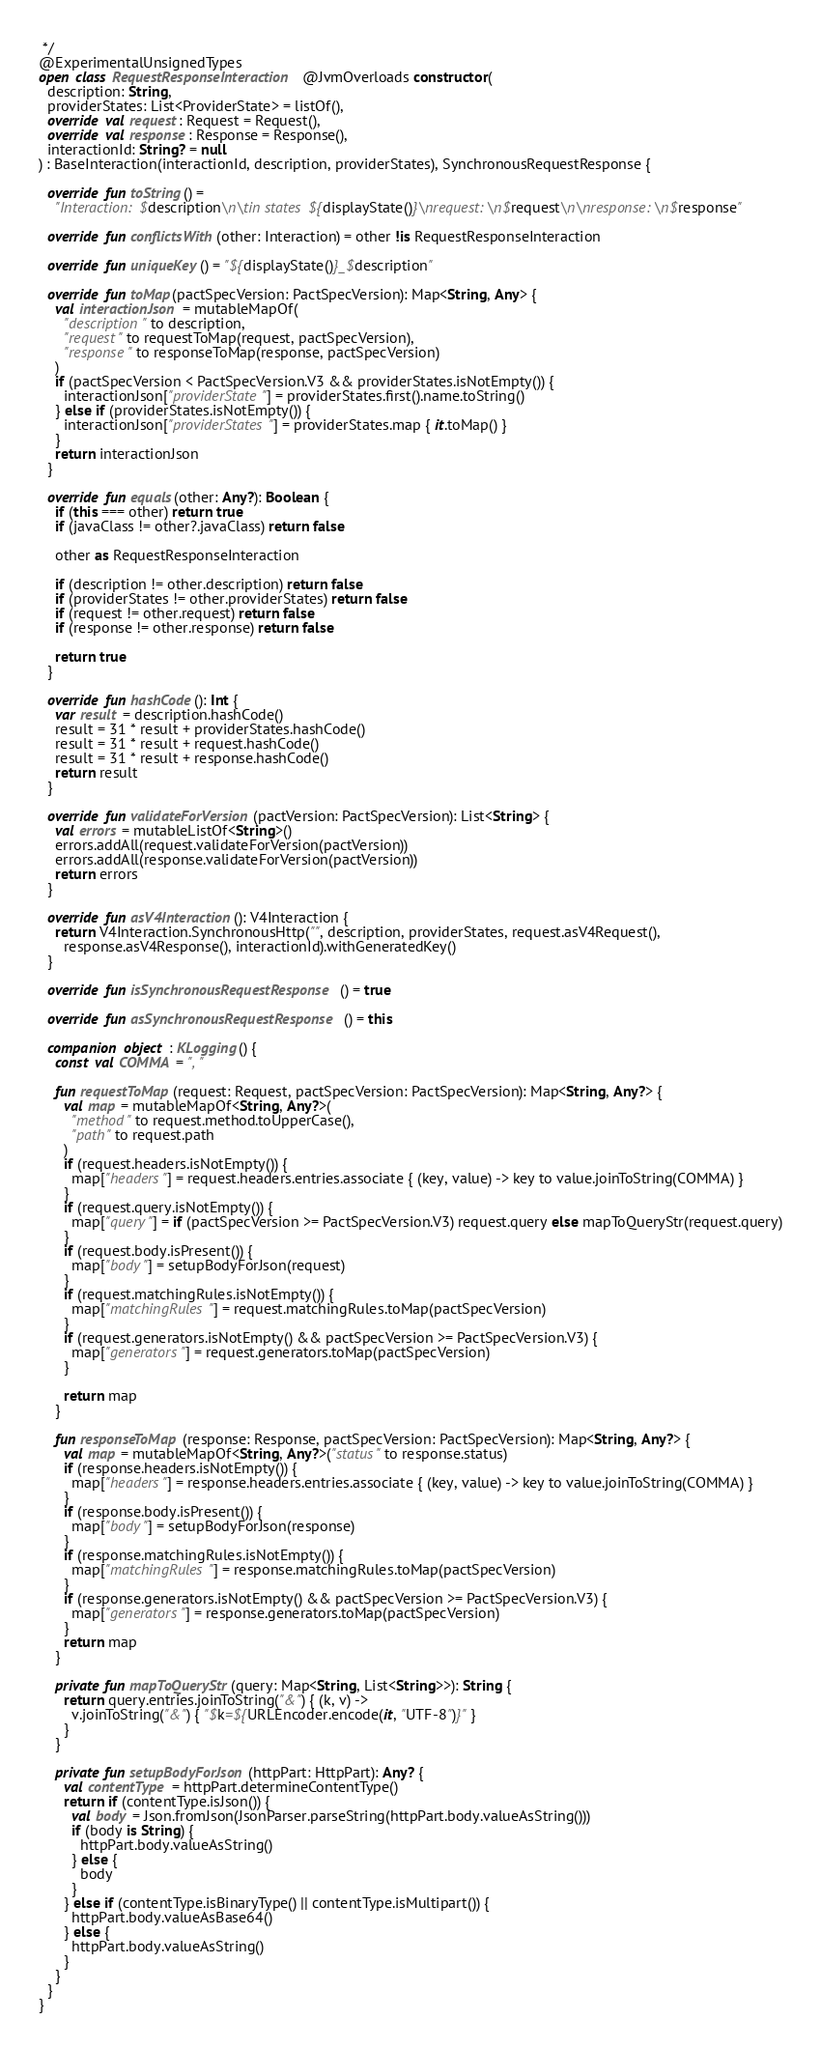<code> <loc_0><loc_0><loc_500><loc_500><_Kotlin_> */
@ExperimentalUnsignedTypes
open class RequestResponseInteraction @JvmOverloads constructor(
  description: String,
  providerStates: List<ProviderState> = listOf(),
  override val request: Request = Request(),
  override val response: Response = Response(),
  interactionId: String? = null
) : BaseInteraction(interactionId, description, providerStates), SynchronousRequestResponse {

  override fun toString() =
    "Interaction: $description\n\tin states ${displayState()}\nrequest:\n$request\n\nresponse:\n$response"

  override fun conflictsWith(other: Interaction) = other !is RequestResponseInteraction

  override fun uniqueKey() = "${displayState()}_$description"

  override fun toMap(pactSpecVersion: PactSpecVersion): Map<String, Any> {
    val interactionJson = mutableMapOf(
      "description" to description,
      "request" to requestToMap(request, pactSpecVersion),
      "response" to responseToMap(response, pactSpecVersion)
    )
    if (pactSpecVersion < PactSpecVersion.V3 && providerStates.isNotEmpty()) {
      interactionJson["providerState"] = providerStates.first().name.toString()
    } else if (providerStates.isNotEmpty()) {
      interactionJson["providerStates"] = providerStates.map { it.toMap() }
    }
    return interactionJson
  }

  override fun equals(other: Any?): Boolean {
    if (this === other) return true
    if (javaClass != other?.javaClass) return false

    other as RequestResponseInteraction

    if (description != other.description) return false
    if (providerStates != other.providerStates) return false
    if (request != other.request) return false
    if (response != other.response) return false

    return true
  }

  override fun hashCode(): Int {
    var result = description.hashCode()
    result = 31 * result + providerStates.hashCode()
    result = 31 * result + request.hashCode()
    result = 31 * result + response.hashCode()
    return result
  }

  override fun validateForVersion(pactVersion: PactSpecVersion): List<String> {
    val errors = mutableListOf<String>()
    errors.addAll(request.validateForVersion(pactVersion))
    errors.addAll(response.validateForVersion(pactVersion))
    return errors
  }

  override fun asV4Interaction(): V4Interaction {
    return V4Interaction.SynchronousHttp("", description, providerStates, request.asV4Request(),
      response.asV4Response(), interactionId).withGeneratedKey()
  }

  override fun isSynchronousRequestResponse() = true

  override fun asSynchronousRequestResponse() = this

  companion object : KLogging() {
    const val COMMA = ", "

    fun requestToMap(request: Request, pactSpecVersion: PactSpecVersion): Map<String, Any?> {
      val map = mutableMapOf<String, Any?>(
        "method" to request.method.toUpperCase(),
        "path" to request.path
      )
      if (request.headers.isNotEmpty()) {
        map["headers"] = request.headers.entries.associate { (key, value) -> key to value.joinToString(COMMA) }
      }
      if (request.query.isNotEmpty()) {
        map["query"] = if (pactSpecVersion >= PactSpecVersion.V3) request.query else mapToQueryStr(request.query)
      }
      if (request.body.isPresent()) {
        map["body"] = setupBodyForJson(request)
      }
      if (request.matchingRules.isNotEmpty()) {
        map["matchingRules"] = request.matchingRules.toMap(pactSpecVersion)
      }
      if (request.generators.isNotEmpty() && pactSpecVersion >= PactSpecVersion.V3) {
        map["generators"] = request.generators.toMap(pactSpecVersion)
      }

      return map
    }

    fun responseToMap(response: Response, pactSpecVersion: PactSpecVersion): Map<String, Any?> {
      val map = mutableMapOf<String, Any?>("status" to response.status)
      if (response.headers.isNotEmpty()) {
        map["headers"] = response.headers.entries.associate { (key, value) -> key to value.joinToString(COMMA) }
      }
      if (response.body.isPresent()) {
        map["body"] = setupBodyForJson(response)
      }
      if (response.matchingRules.isNotEmpty()) {
        map["matchingRules"] = response.matchingRules.toMap(pactSpecVersion)
      }
      if (response.generators.isNotEmpty() && pactSpecVersion >= PactSpecVersion.V3) {
        map["generators"] = response.generators.toMap(pactSpecVersion)
      }
      return map
    }

    private fun mapToQueryStr(query: Map<String, List<String>>): String {
      return query.entries.joinToString("&") { (k, v) ->
        v.joinToString("&") { "$k=${URLEncoder.encode(it, "UTF-8")}" }
      }
    }

    private fun setupBodyForJson(httpPart: HttpPart): Any? {
      val contentType = httpPart.determineContentType()
      return if (contentType.isJson()) {
        val body = Json.fromJson(JsonParser.parseString(httpPart.body.valueAsString()))
        if (body is String) {
          httpPart.body.valueAsString()
        } else {
          body
        }
      } else if (contentType.isBinaryType() || contentType.isMultipart()) {
        httpPart.body.valueAsBase64()
      } else {
        httpPart.body.valueAsString()
      }
    }
  }
}
</code> 